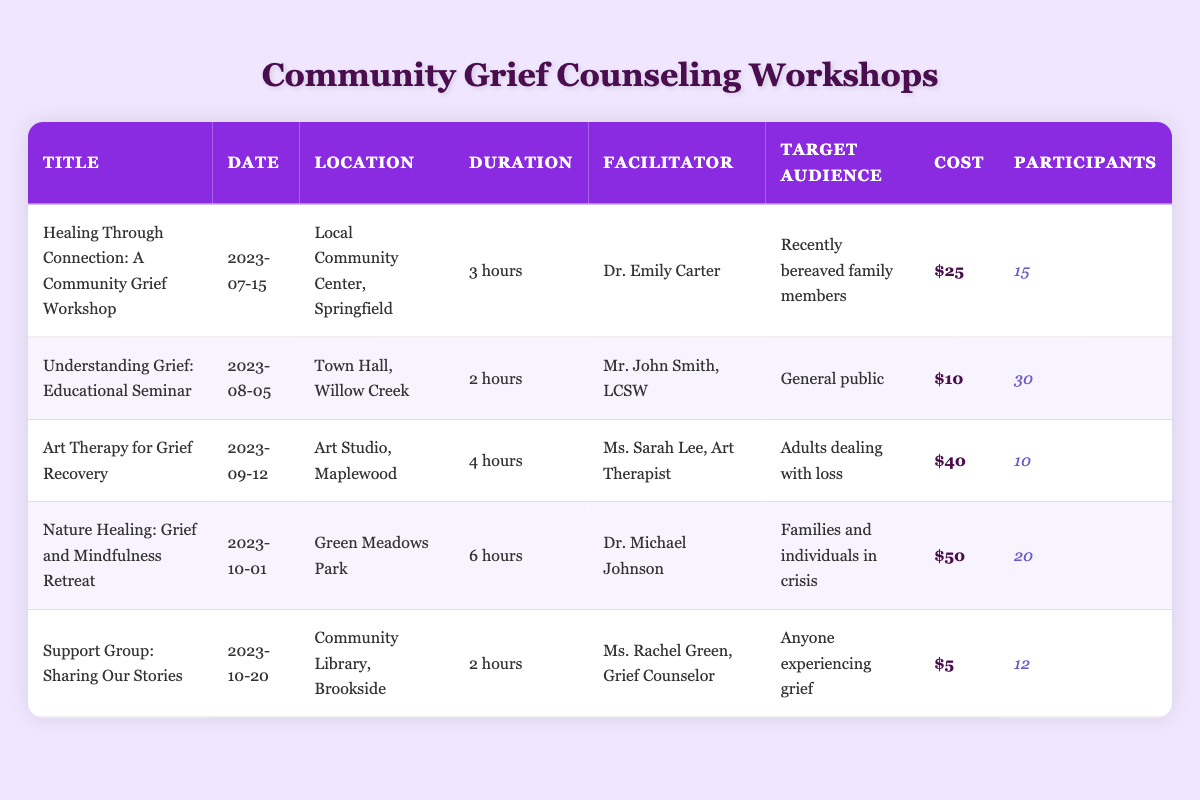What is the title of the workshop scheduled on 2023-09-12? The table lists the workshops along with their respective dates. Looking at the date column for 2023-09-12, we find the corresponding title "Art Therapy for Grief Recovery."
Answer: Art Therapy for Grief Recovery Who is the facilitator for the "Understanding Grief: Educational Seminar"? By scanning the table for the title "Understanding Grief: Educational Seminar," we look across to find the facilitator's name listed in the corresponding row, which is Mr. John Smith, LCSW.
Answer: Mr. John Smith, LCSW How many participants attended the "Healing Through Connection: A Community Grief Workshop"? The number of participants for the workshop titled "Healing Through Connection: A Community Grief Workshop" can be found in its row under the 'Participants' column, which shows 15 participants.
Answer: 15 What is the total cost for a participant to attend the "Nature Healing: Grief and Mindfulness Retreat"? The cost for attending this particular workshop, found in the respective row under the 'Cost' column, is $50.
Answer: $50 Did more than 20 people attend the "Art Therapy for Grief Recovery" workshop? To answer this yes/no question, we check the participants count for "Art Therapy for Grief Recovery," which is 10. Since 10 is not greater than 20, the answer is no.
Answer: No What is the average duration of the workshops listed? To calculate the average duration, we first convert the durations into hours: 3, 2, 4, 6, and 2. The sum is 3 + 2 + 4 + 6 + 2 = 17 hours. The number of workshops is 5. Thus, the average duration is 17 hours divided by 5, which is 3.4 hours.
Answer: 3.4 hours Is there a workshop specifically for adults dealing with loss? By checking the 'Target Audience' column for each workshop, we find that "Art Therapy for Grief Recovery" targets "Adults dealing with loss," confirming this is true.
Answer: Yes Which workshop had the highest cost per participant? We analyze the 'Cost' column for each workshop: $25, $10, $40, $50, and $5. The highest value among these is $50 from the "Nature Healing: Grief and Mindfulness Retreat."
Answer: $50 What is the total number of participants across all workshops? We sum the participants from each workshop: 15 + 30 + 10 + 20 + 12 = 87. Therefore, the total number of participants is 87.
Answer: 87 